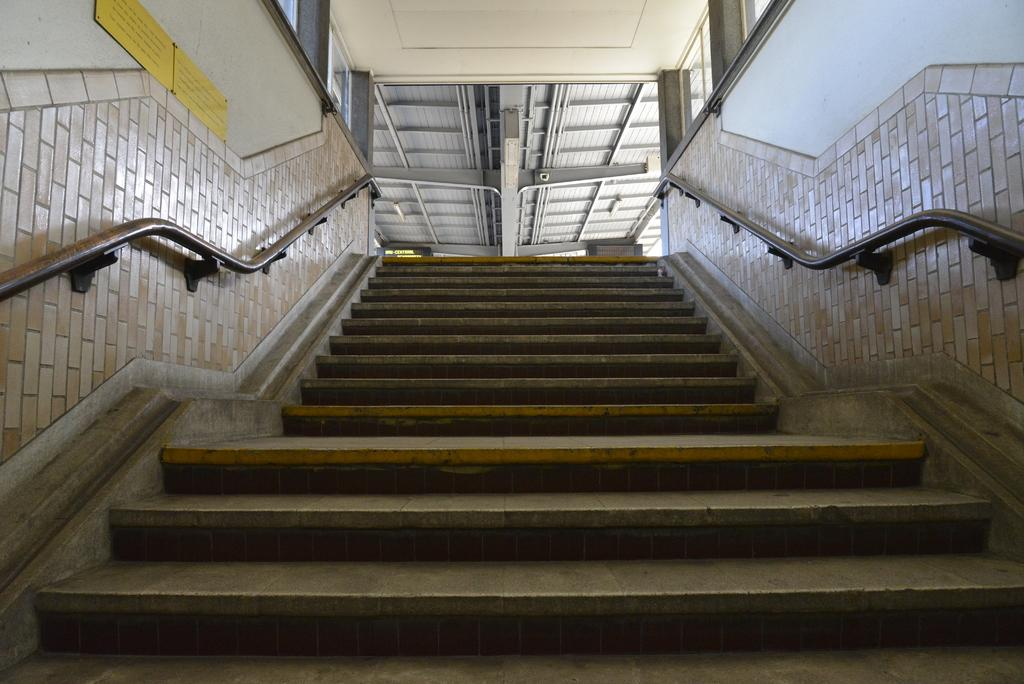What is the main feature in the center of the image? There is a staircase in the center of the image. What can be seen in the background of the image? In the background of the image, there is a wall, fences, banners, pillars, and other objects. What is written on the banners? There is text on the banners. How many spiders are crawling on the staircase in the image? There are no spiders visible on the staircase or anywhere else in the image. What is the chance of winning a prize in the image? There is no indication of a prize or any game of chance in the image. 